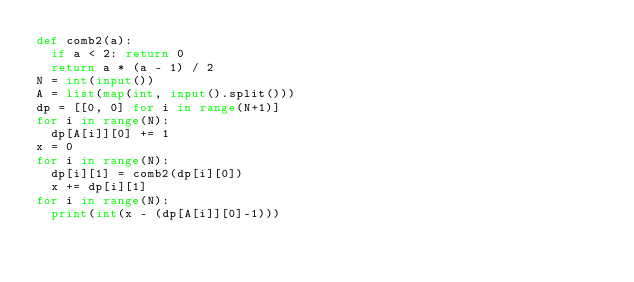Convert code to text. <code><loc_0><loc_0><loc_500><loc_500><_Python_>def comb2(a):
  if a < 2: return 0
  return a * (a - 1) / 2
N = int(input())
A = list(map(int, input().split()))
dp = [[0, 0] for i in range(N+1)]
for i in range(N):
  dp[A[i]][0] += 1
x = 0
for i in range(N):
  dp[i][1] = comb2(dp[i][0])
  x += dp[i][1]
for i in range(N):
  print(int(x - (dp[A[i]][0]-1)))</code> 